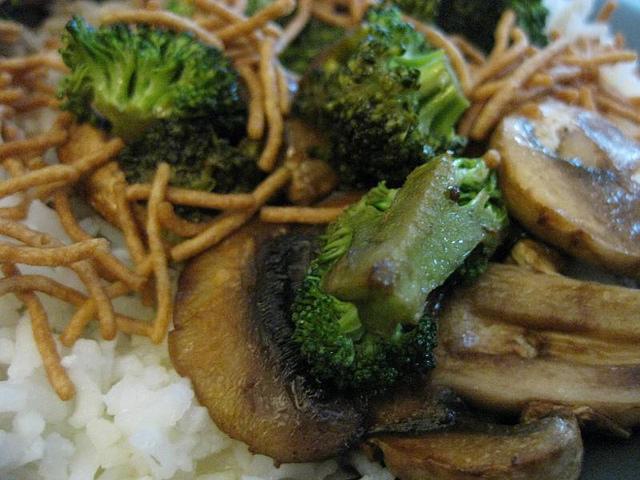Are the plants live?
Short answer required. No. What is the green vegetable?
Quick response, please. Broccoli. Has the broccoli been finely chopped up?
Concise answer only. No. How many noodles on plate?
Be succinct. Many. What is green?
Concise answer only. Broccoli. 